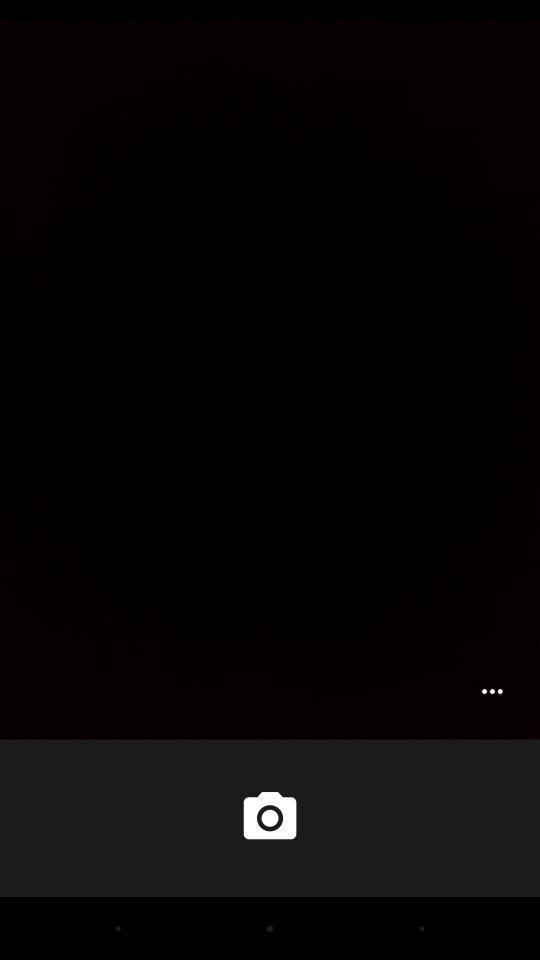Describe this image in words. More option showing in this page. 